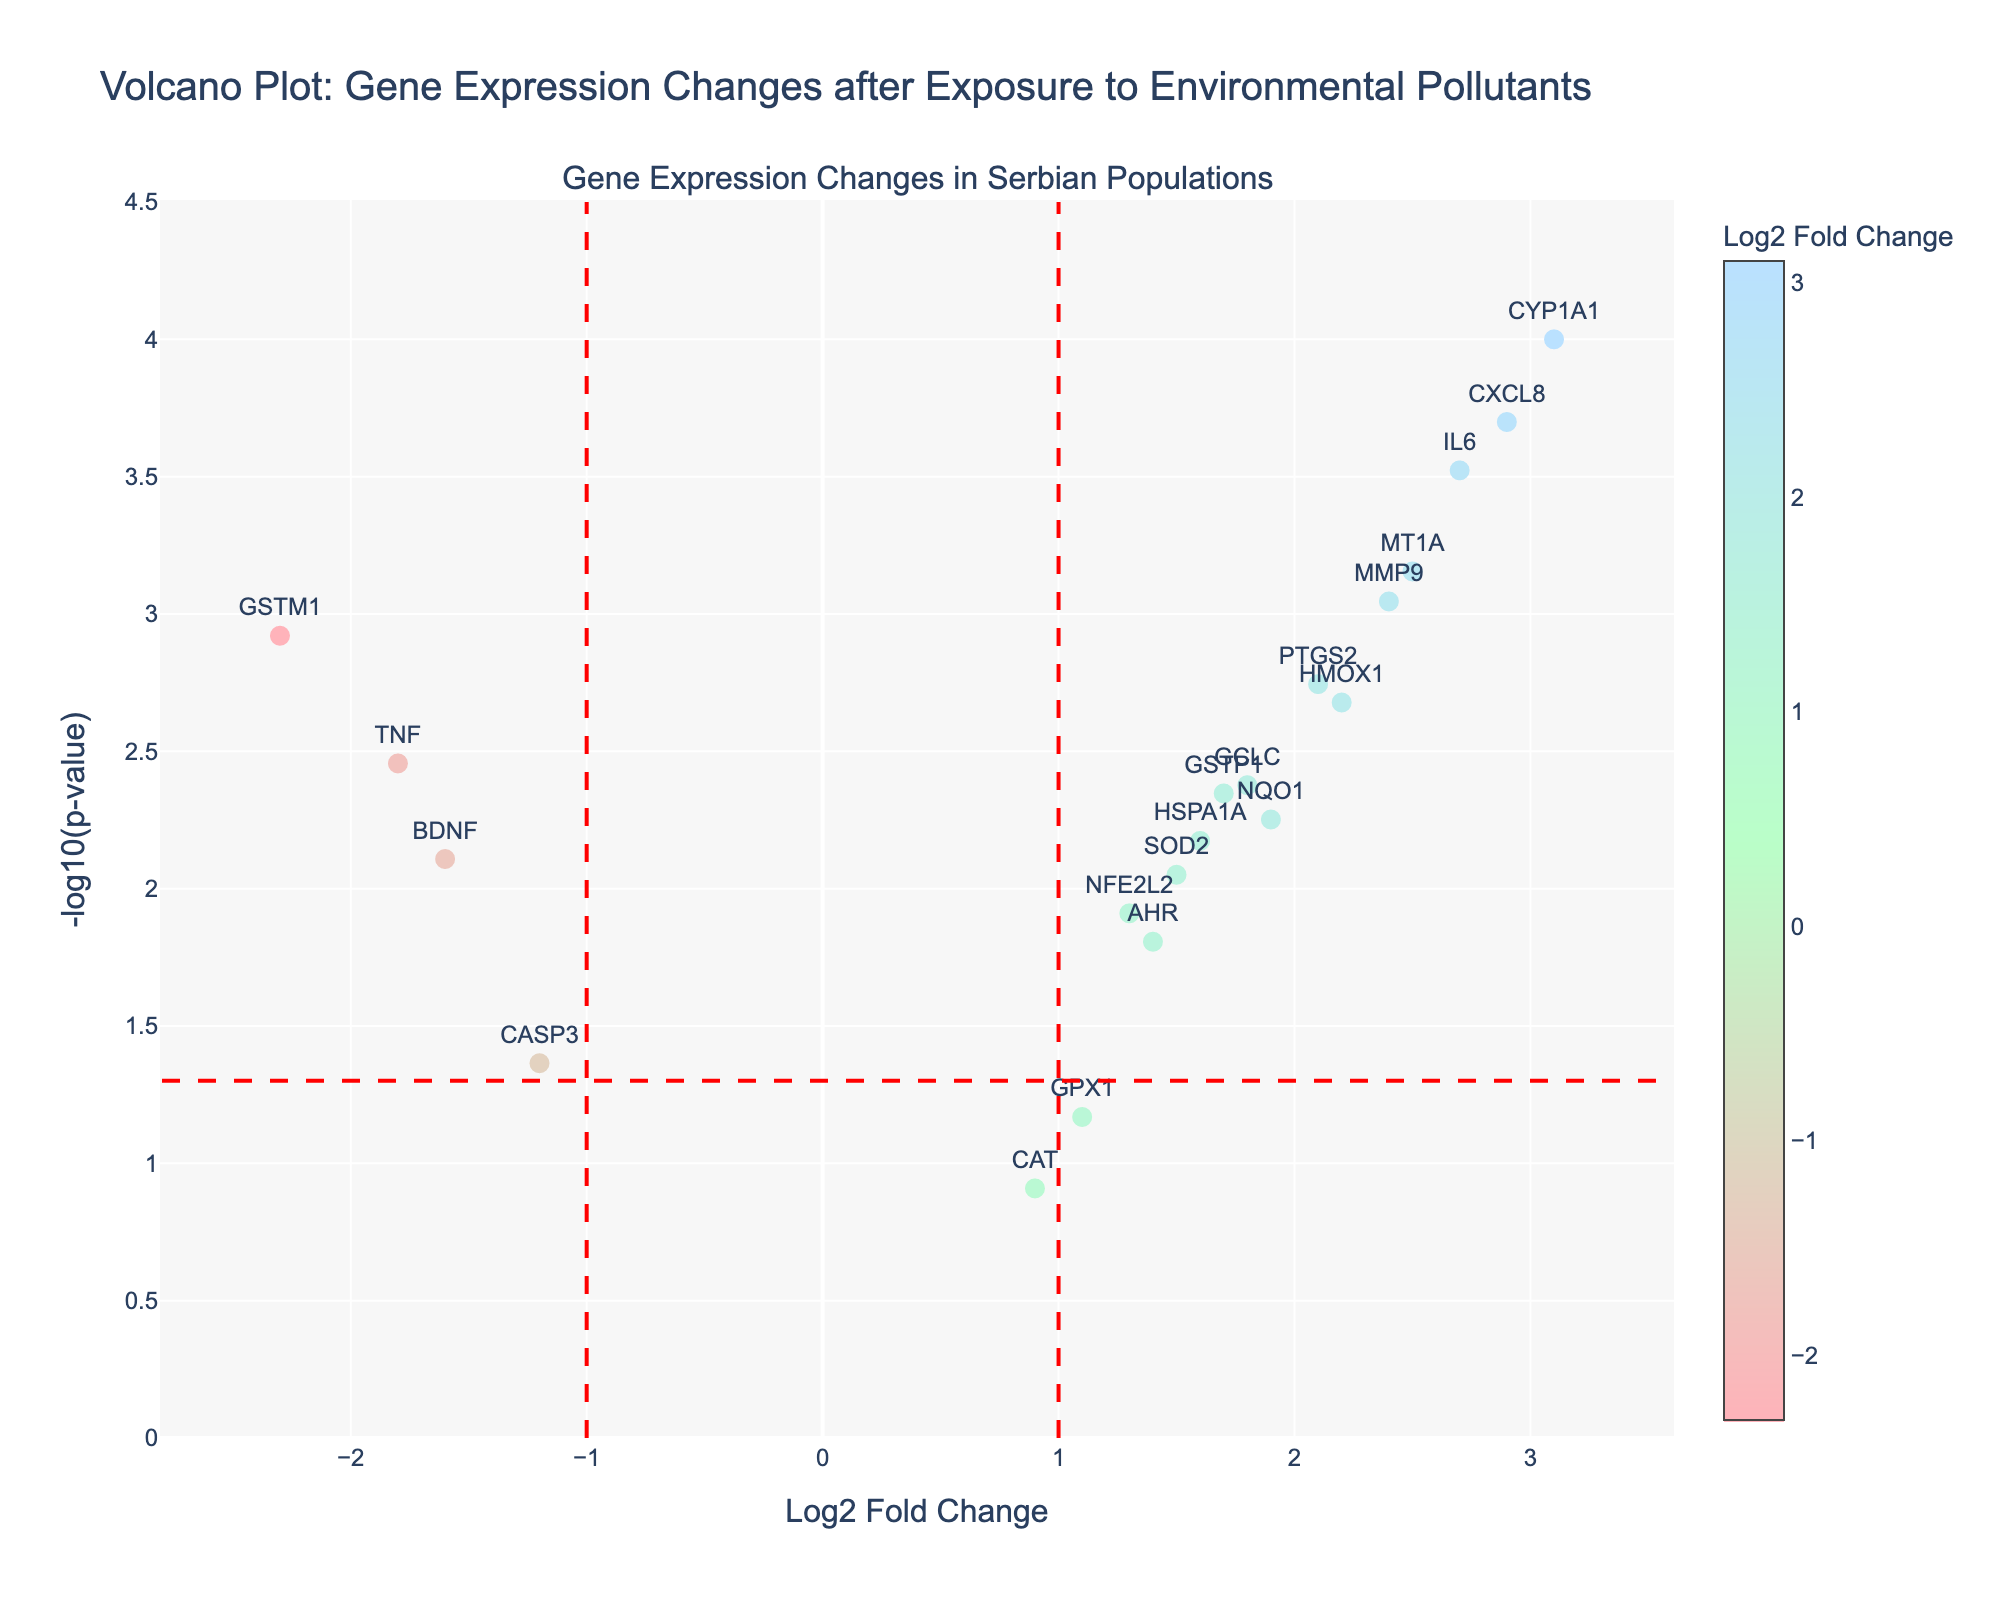How many genes have been plotted in the figure? You can count each data point (gene) plotted on the figure. By counting all the data points, we can see there are 20 genes plotted.
Answer: 20 What is the title of the plot? The title is clearly mentioned at the top of the figure as "Volcano Plot: Gene Expression Changes after Exposure to Environmental Pollutants"
Answer: Volcano Plot: Gene Expression Changes after Exposure to Environmental Pollutants Which gene has the highest -log10(p-value)? You need to identify the data point that is highest on the y-axis, as it represents the highest -log10(p-value). The highest point on the y-axis corresponds to the gene CYP1A1.
Answer: CYP1A1 Which gene has the lowest Log2 Fold Change? To find this, look for the data point furthest to the left on the x-axis. The leftmost point corresponds to the gene GSTM1.
Answer: GSTM1 How many genes have a Log2 Fold Change greater than 2? By looking at the x-axis and counting the number of points to the right of the vertical line at Log2 Fold Change = 2, you can count 5 genes: CYP1A1, IL6, MT1A, CXCL8, and MMP9.
Answer: 5 Which gene is at the intersection of the horizontal line (p-value = 0.05) and to the right of the vertical line at Log2 Fold Change = 1? The horizontal line at -log10(p-value) ≈ 1.301 indicates a p-value of 0.05, and the vertical line at Log2 Fold Change = 1 splits the plot vertically. The gene HMOX1 is closest to this intersection while being to the right of the vertical line.
Answer: HMOX1 Among the genes with a Log2 Fold Change less than 0, which gene has the smallest -log10(p-value)? From the genes with Log2 Fold Change < 0 (points to the left of the y-axis), the one with the smallest -log10(p-value) is the lowest among them on the y-axis. The gene CASP3 is the lowest.
Answer: CASP3 Compare the Log2 Fold Change and -log10(p-value) of genes GSTP1 and BDNF. Which has a higher fold change, and which is more significant? For higher fold change, compare Log2 Fold Change: GSTP1 (1.7) > BDNF (-1.6). For significance, compare -log10(p-value): GSTP1 (≈2.35) > BDNF (≈2.11). Thus, GSTP1 has both a higher fold change and is more significant.
Answer: GSTP1 Which gene has the highest p-value among those with a Log2 Fold Change greater than 1? Among the genes to the right of the vertical line at Log2 Fold Change = 1, check the hover information for the highest p-value. GPX1, with Log2 Fold Change of 1.1 and p-value = 0.0678, has the highest p-value among them.
Answer: GPX1 What is the Log2 Fold Change of the gene SOD2? Look for the data point labeled SOD2 and refer to its position on the x-axis or the hover information to find the Log2 Fold Change. SOD2 has a Log2 Fold Change of 1.5.
Answer: 1.5 